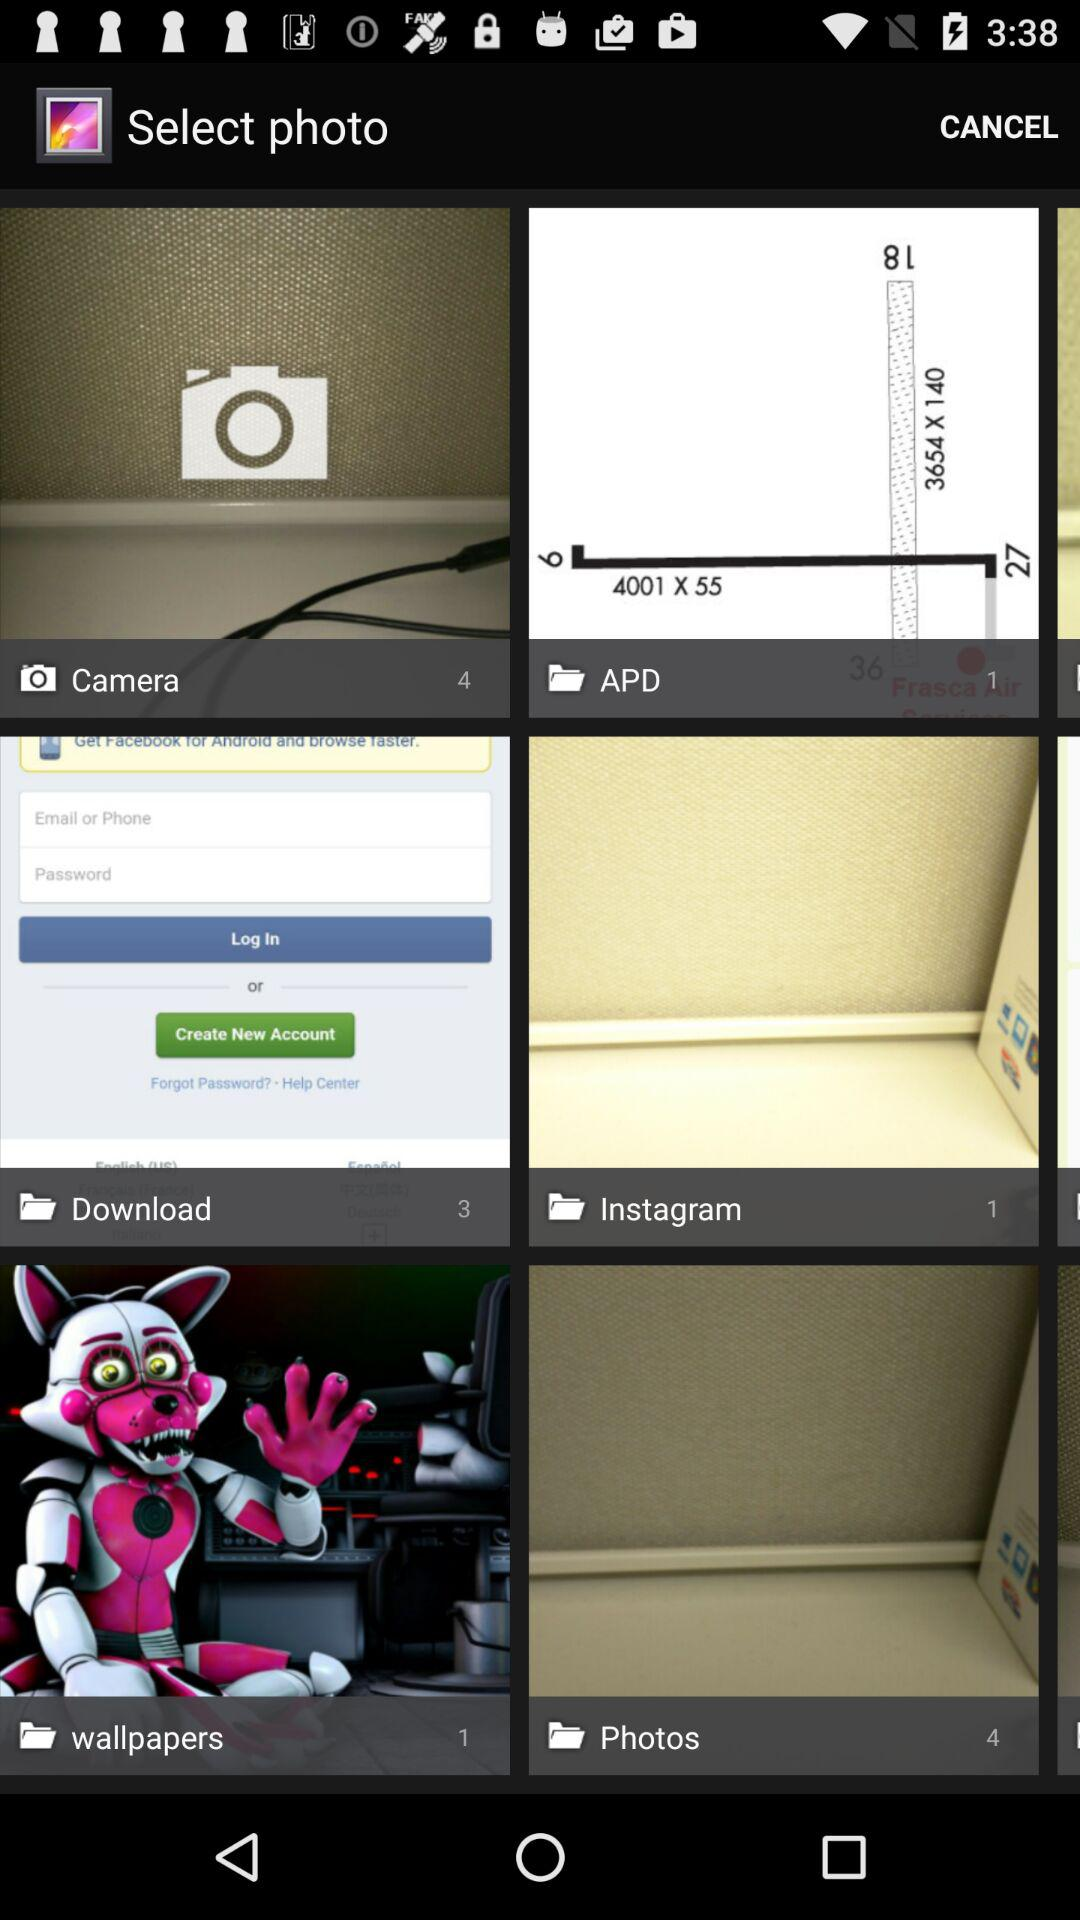How many photos are there in the "Camera" folder? There are 4 photos in the "Camera" folder. 